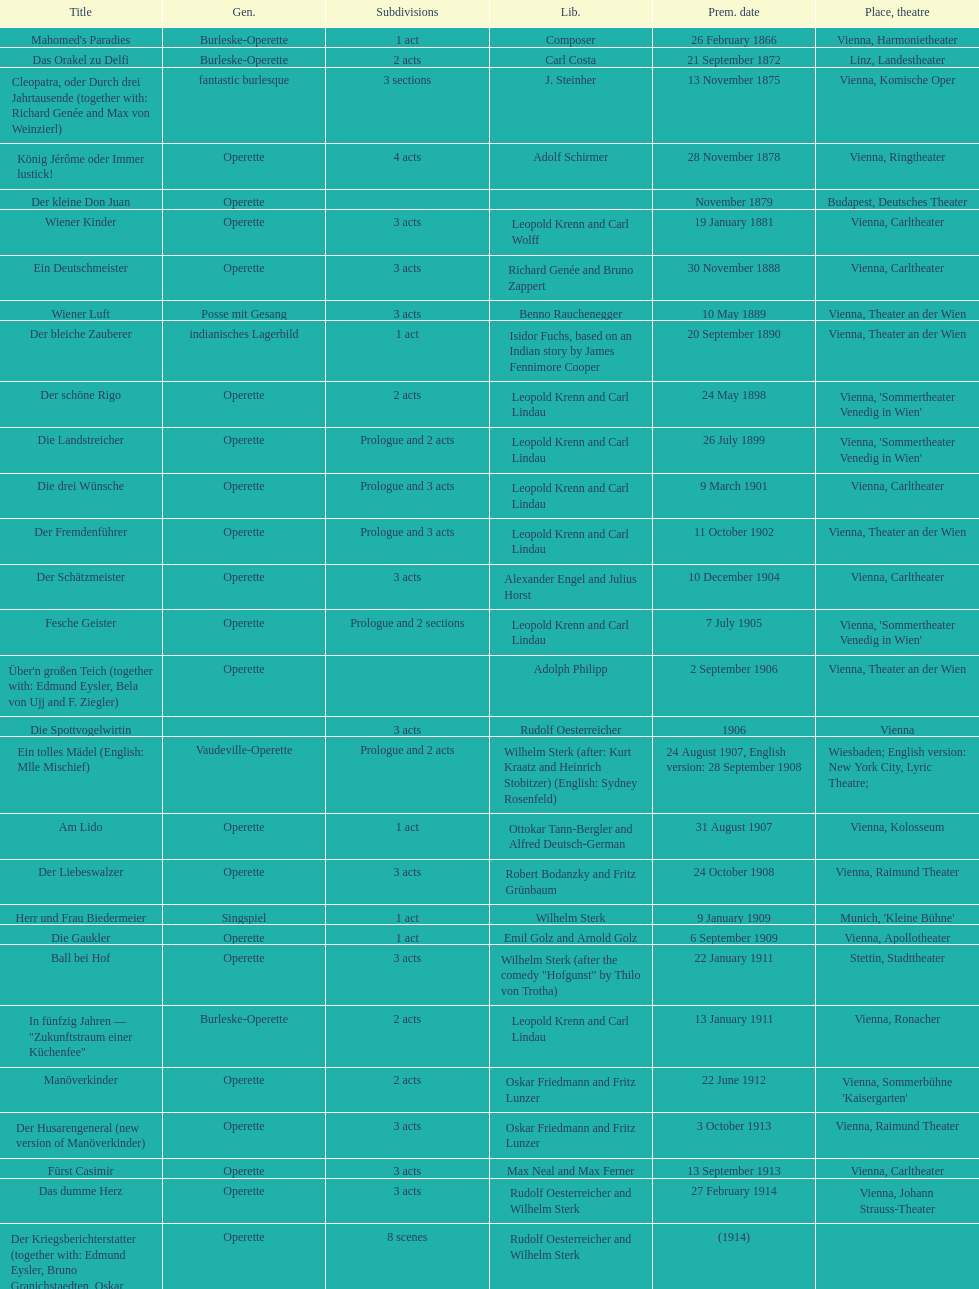In which city did the most operettas premiere? Vienna. 